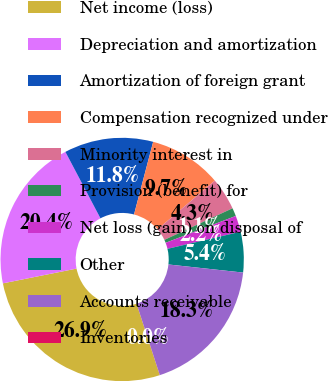Convert chart to OTSL. <chart><loc_0><loc_0><loc_500><loc_500><pie_chart><fcel>Net income (loss)<fcel>Depreciation and amortization<fcel>Amortization of foreign grant<fcel>Compensation recognized under<fcel>Minority interest in<fcel>Provision (benefit) for<fcel>Net loss (gain) on disposal of<fcel>Other<fcel>Accounts receivable<fcel>Inventories<nl><fcel>26.86%<fcel>20.42%<fcel>11.83%<fcel>9.68%<fcel>4.31%<fcel>1.09%<fcel>2.16%<fcel>5.38%<fcel>18.27%<fcel>0.01%<nl></chart> 